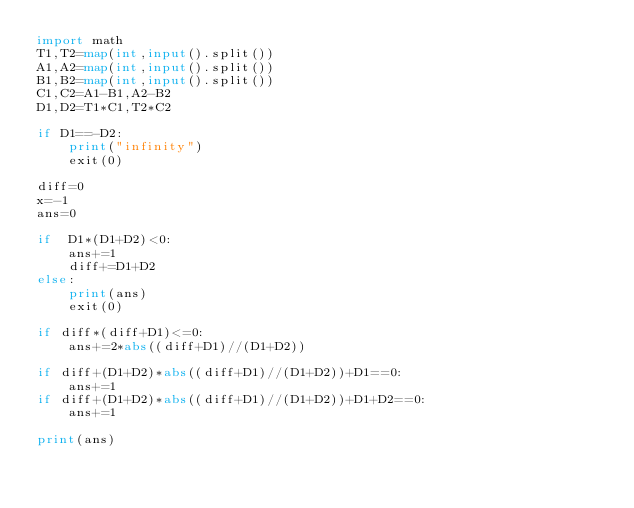Convert code to text. <code><loc_0><loc_0><loc_500><loc_500><_Python_>import math
T1,T2=map(int,input().split())
A1,A2=map(int,input().split())
B1,B2=map(int,input().split())
C1,C2=A1-B1,A2-B2
D1,D2=T1*C1,T2*C2

if D1==-D2:
    print("infinity")
    exit(0)

diff=0
x=-1
ans=0

if  D1*(D1+D2)<0:
    ans+=1
    diff+=D1+D2
else:
    print(ans)
    exit(0)

if diff*(diff+D1)<=0:
    ans+=2*abs((diff+D1)//(D1+D2))

if diff+(D1+D2)*abs((diff+D1)//(D1+D2))+D1==0:
    ans+=1
if diff+(D1+D2)*abs((diff+D1)//(D1+D2))+D1+D2==0:
    ans+=1

print(ans)</code> 